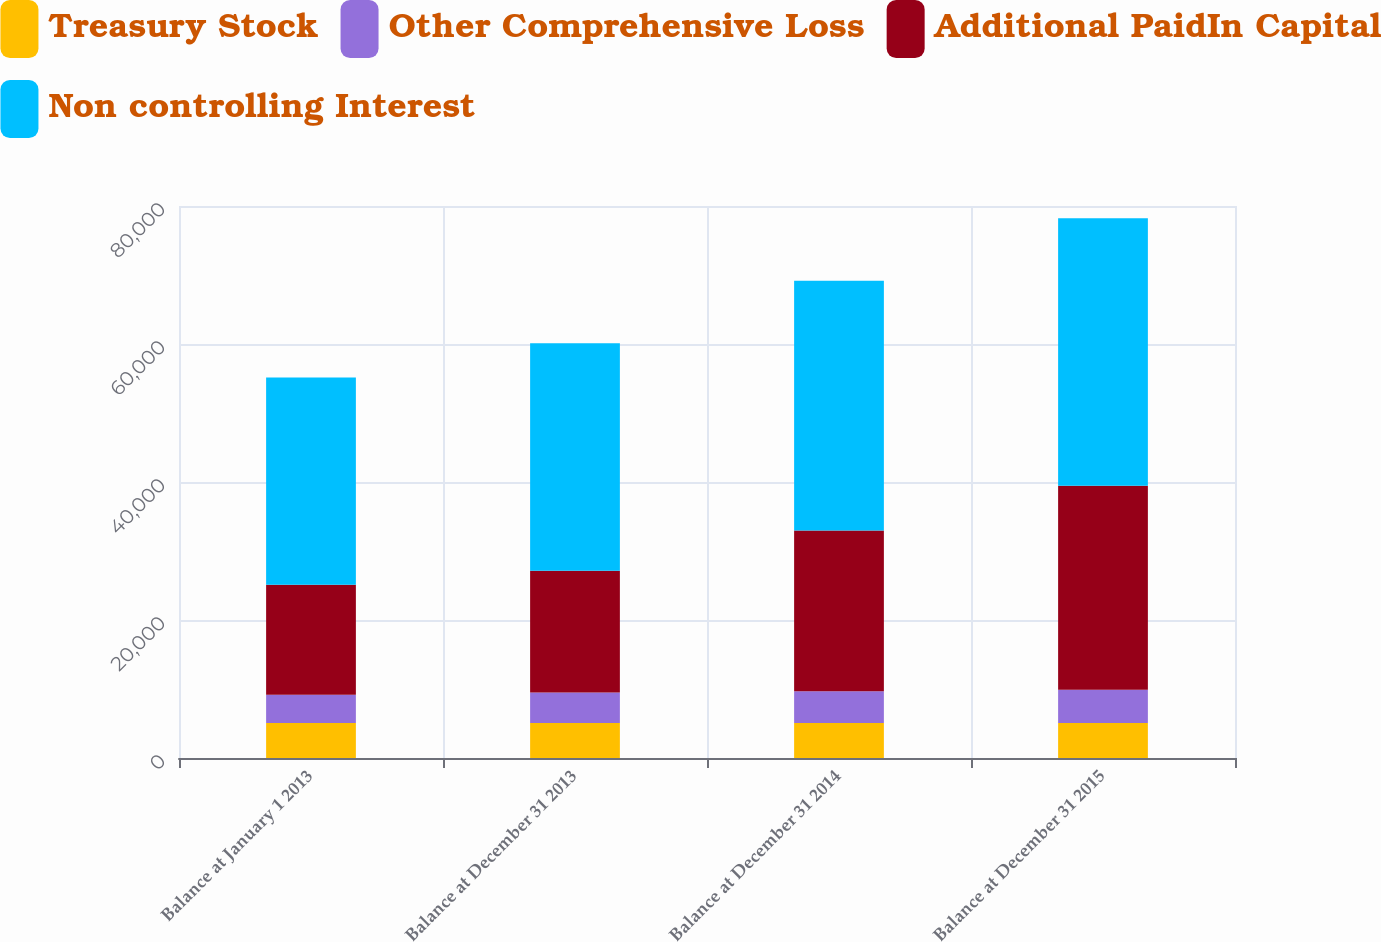Convert chart. <chart><loc_0><loc_0><loc_500><loc_500><stacked_bar_chart><ecel><fcel>Balance at January 1 2013<fcel>Balance at December 31 2013<fcel>Balance at December 31 2014<fcel>Balance at December 31 2015<nl><fcel>Treasury Stock<fcel>5061<fcel>5061<fcel>5061<fcel>5061<nl><fcel>Other Comprehensive Loss<fcel>4122<fcel>4415<fcel>4625<fcel>4834<nl><fcel>Additional PaidIn Capital<fcel>15937<fcel>17671<fcel>23298<fcel>29568<nl><fcel>Non controlling Interest<fcel>30037<fcel>32964<fcel>36180<fcel>38756<nl></chart> 